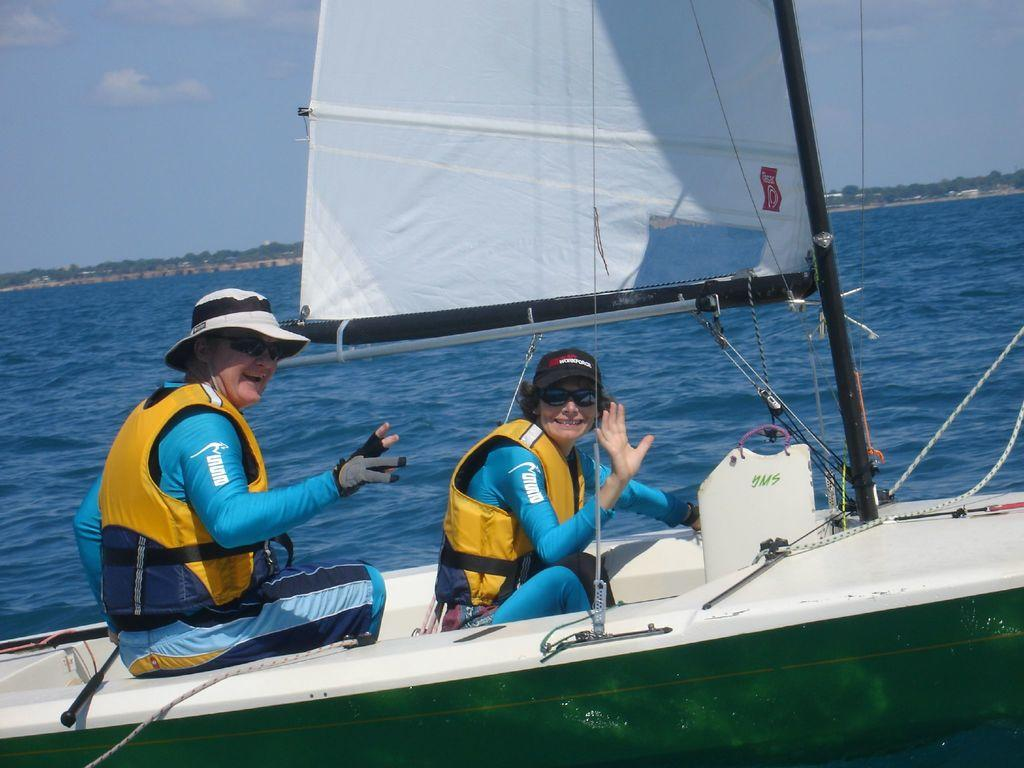How many people are in the image? There are two ladies in the image. What are the ladies doing in the image? The ladies are sitting in a ship. What can be seen in the background of the image? There are trees, water, and the sky visible in the background of the image. What type of chicken can be seen swimming in the water in the image? There are no chickens present in the image; the ladies are sitting in a ship, and the background features trees, water, and the sky. 